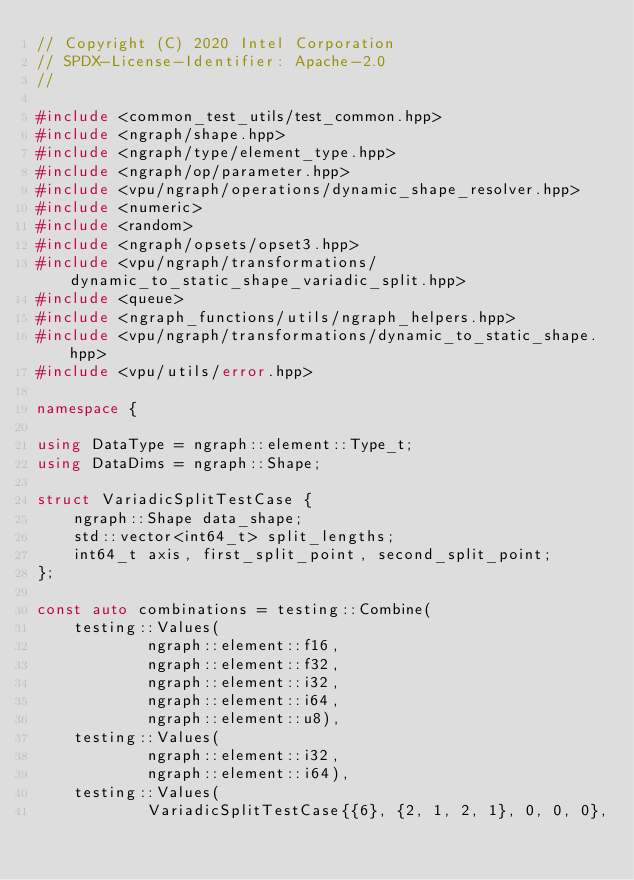Convert code to text. <code><loc_0><loc_0><loc_500><loc_500><_C++_>// Copyright (C) 2020 Intel Corporation
// SPDX-License-Identifier: Apache-2.0
//

#include <common_test_utils/test_common.hpp>
#include <ngraph/shape.hpp>
#include <ngraph/type/element_type.hpp>
#include <ngraph/op/parameter.hpp>
#include <vpu/ngraph/operations/dynamic_shape_resolver.hpp>
#include <numeric>
#include <random>
#include <ngraph/opsets/opset3.hpp>
#include <vpu/ngraph/transformations/dynamic_to_static_shape_variadic_split.hpp>
#include <queue>
#include <ngraph_functions/utils/ngraph_helpers.hpp>
#include <vpu/ngraph/transformations/dynamic_to_static_shape.hpp>
#include <vpu/utils/error.hpp>

namespace {

using DataType = ngraph::element::Type_t;
using DataDims = ngraph::Shape;

struct VariadicSplitTestCase {
    ngraph::Shape data_shape;
    std::vector<int64_t> split_lengths;
    int64_t axis, first_split_point, second_split_point;
};

const auto combinations = testing::Combine(
    testing::Values(
            ngraph::element::f16,
            ngraph::element::f32,
            ngraph::element::i32,
            ngraph::element::i64,
            ngraph::element::u8),
    testing::Values(
            ngraph::element::i32,
            ngraph::element::i64),
    testing::Values(
            VariadicSplitTestCase{{6}, {2, 1, 2, 1}, 0, 0, 0},</code> 